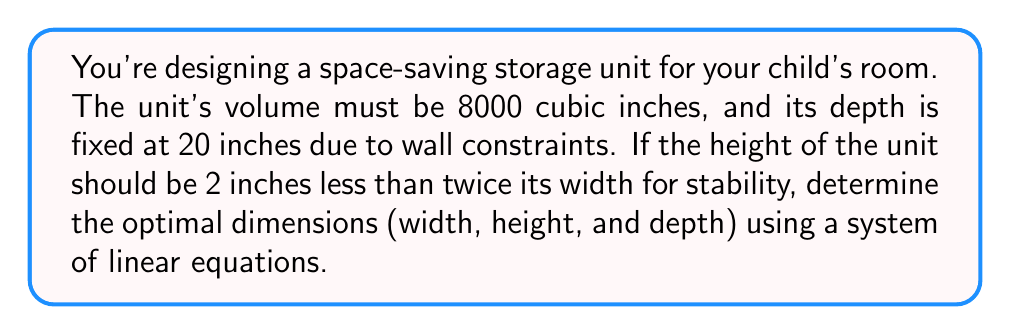Could you help me with this problem? Let's approach this step-by-step:

1) Let $w$ be the width and $h$ be the height of the storage unit.

2) We're given that the depth is 20 inches and the volume is 8000 cubic inches. This gives us our first equation:
   
   $$ w \cdot h \cdot 20 = 8000 $$

3) We're also told that the height should be 2 inches less than twice the width. This gives us our second equation:
   
   $$ h = 2w - 2 $$

4) Now, let's substitute the second equation into the first:
   
   $$ w \cdot (2w - 2) \cdot 20 = 8000 $$

5) Expand this equation:
   
   $$ 40w^2 - 40w = 8000 $$

6) Rearrange to standard quadratic form:
   
   $$ 40w^2 - 40w - 8000 = 0 $$

7) Divide everything by 40:
   
   $$ w^2 - w - 200 = 0 $$

8) Use the quadratic formula to solve for $w$:
   
   $$ w = \frac{1 \pm \sqrt{1^2 - 4(1)(-200)}}{2(1)} = \frac{1 \pm \sqrt{801}}{2} $$

9) Since width can't be negative, we take the positive root:
   
   $$ w = \frac{1 + \sqrt{801}}{2} \approx 14.17 \text{ inches} $$

10) Round to the nearest whole number for practicality: $w = 14$ inches

11) Now we can find $h$ using our second equation:
    
    $$ h = 2(14) - 2 = 26 \text{ inches} $$

Therefore, the optimal dimensions are:
Width = 14 inches, Height = 26 inches, Depth = 20 inches
Answer: 14" x 26" x 20" 